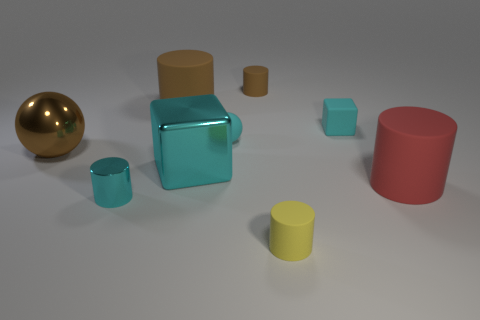How many brown cylinders must be subtracted to get 1 brown cylinders? 1 Add 1 gray metal cylinders. How many objects exist? 10 Subtract all tiny brown cylinders. How many cylinders are left? 4 Subtract all blocks. How many objects are left? 7 Subtract all cyan cylinders. How many cylinders are left? 4 Subtract 1 blocks. How many blocks are left? 1 Subtract all small red shiny blocks. Subtract all cyan metallic cylinders. How many objects are left? 8 Add 7 brown balls. How many brown balls are left? 8 Add 6 metallic balls. How many metallic balls exist? 7 Subtract 0 blue balls. How many objects are left? 9 